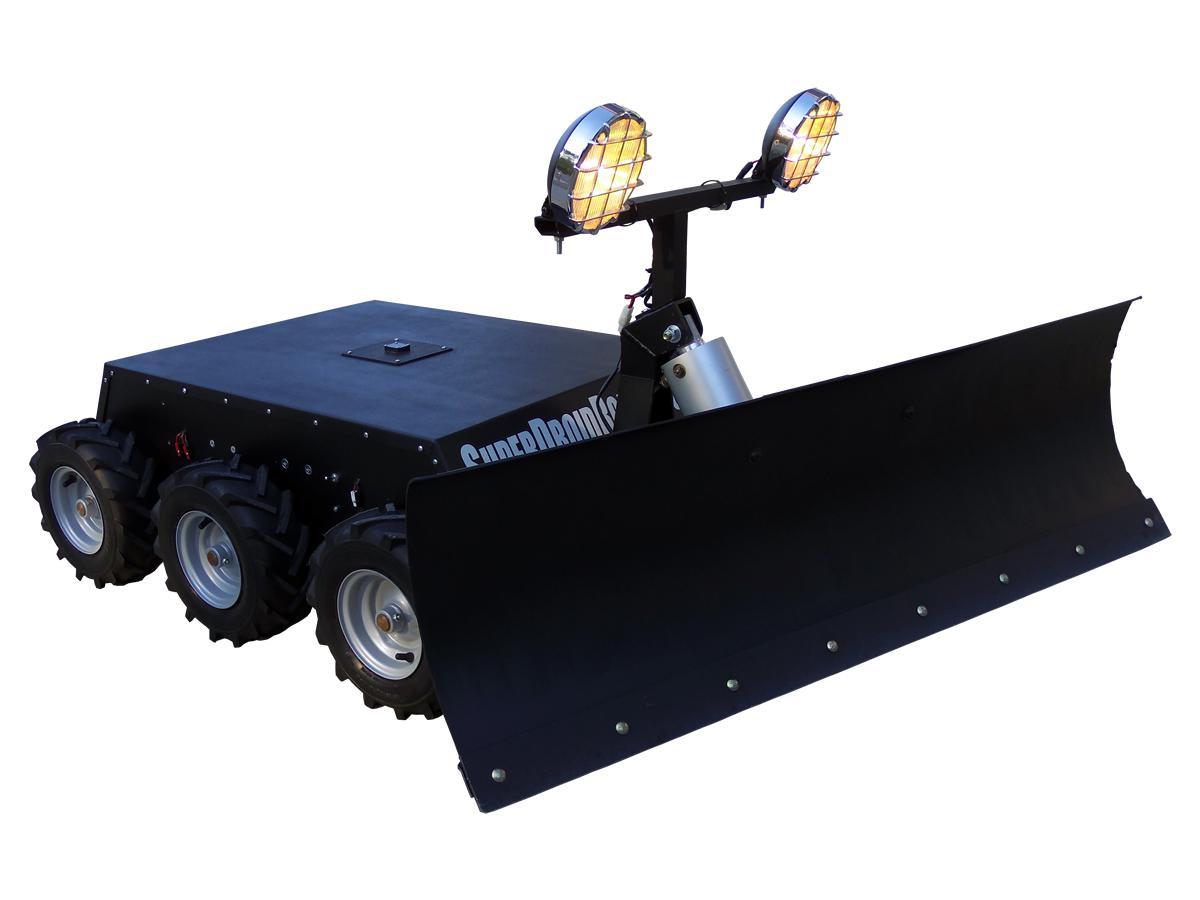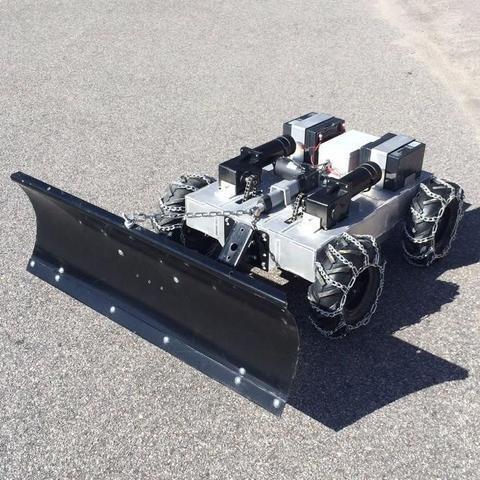The first image is the image on the left, the second image is the image on the right. Analyze the images presented: Is the assertion "The plows in the left and right images face opposite directions, and the left image features an orange plow on a surface without snow, while the right image features a green vehicle on a snow-covered surface." valid? Answer yes or no. No. The first image is the image on the left, the second image is the image on the right. Assess this claim about the two images: "The left and right image contains the same number of snow vehicle with at least one green vehicle.". Correct or not? Answer yes or no. No. 